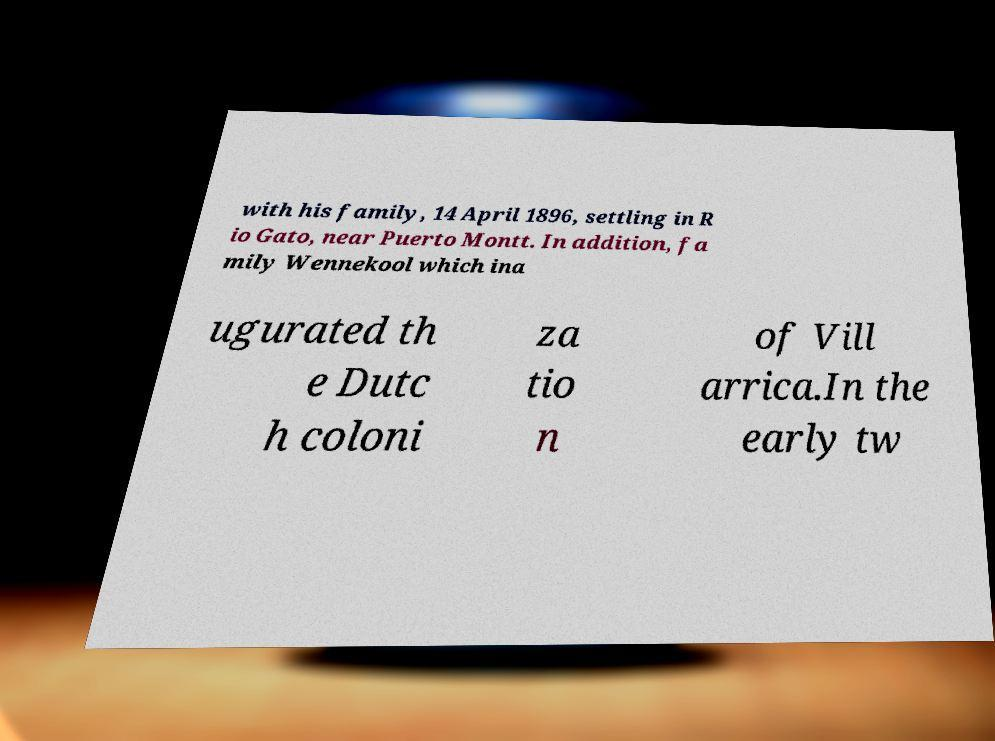Please identify and transcribe the text found in this image. with his family, 14 April 1896, settling in R io Gato, near Puerto Montt. In addition, fa mily Wennekool which ina ugurated th e Dutc h coloni za tio n of Vill arrica.In the early tw 